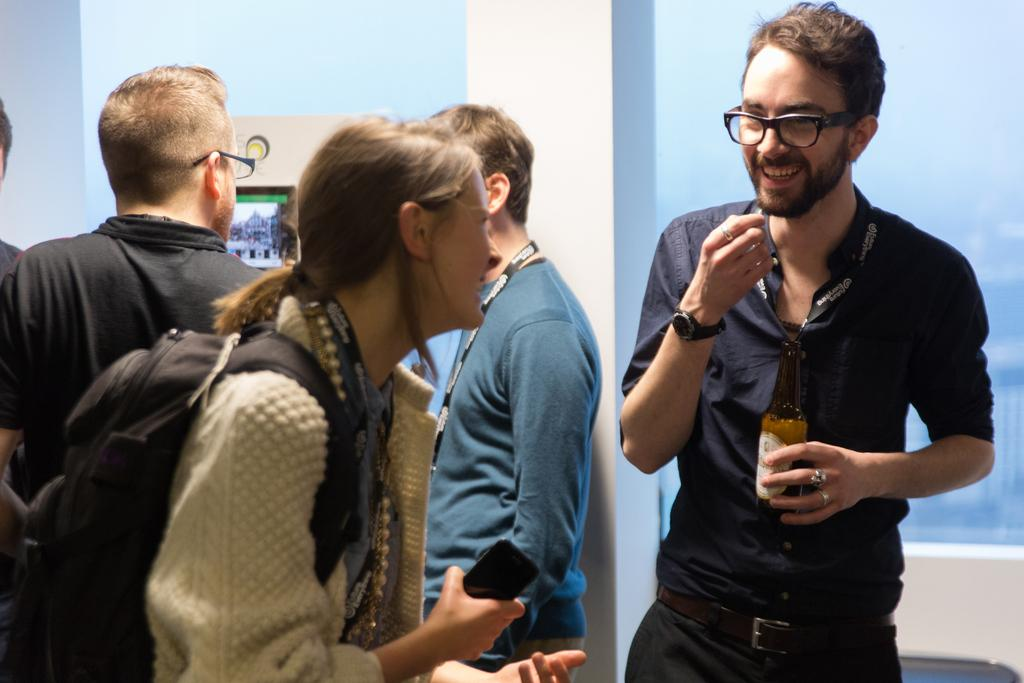How many people are present in the image? There are five people in the image. Can you describe the expressions of the people in the image? Two of the people are smiling. What is one architectural feature visible in the image? There is a pillar in the image. What type of object can be seen in the image that is typically used for displaying information or advertisements? There is a poster in the image. What item might be used for carrying personal belongings in the image? There is a bag in the image. What type of container is visible in the image that might hold a liquid? There is a bottle in the image. What type of device can be seen in the image that is used for communication? There is a mobile in the image. What is one unspecified object present in the image? There are some unspecified objects in the image. What is visible in the background of the image that is made of a transparent material? The background of the image includes glass. Can you tell me how many cherries are on the horse in the image? There is no horse or cherries present in the image. What type of approval is being given by the people in the image? There is no indication of approval or disapproval in the image; it only shows people, a pillar, a poster, a bag, a bottle, a mobile, and some unspecified objects. 